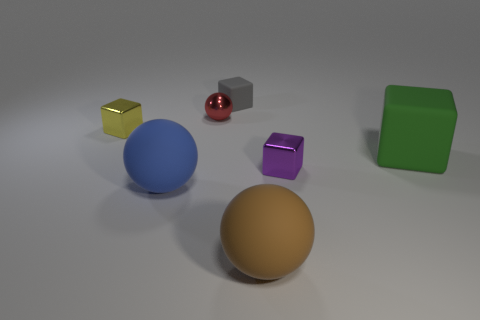Can you describe the differences between the objects in the image? Certainly! The image displays six objects with varied shapes, colors, and materials. Starting from the left, there's a small golden cube with a shiny surface, suggesting it may be metallic. Next to it is a larger blue sphere, which has a smooth surface, likely a plastic or painted object. Towards the center, we have a small red sphere with a high gloss finish, resembling a rubber material, and a purple cube with a reflective surface. The large green object is a cube with a matte finish, probably a plastic block. Finally, we see a large orange sphere to the right with a surface texture that may indicate it's a clay or terracotta object. Each object captures the light differently, indicating a unique material composition. 